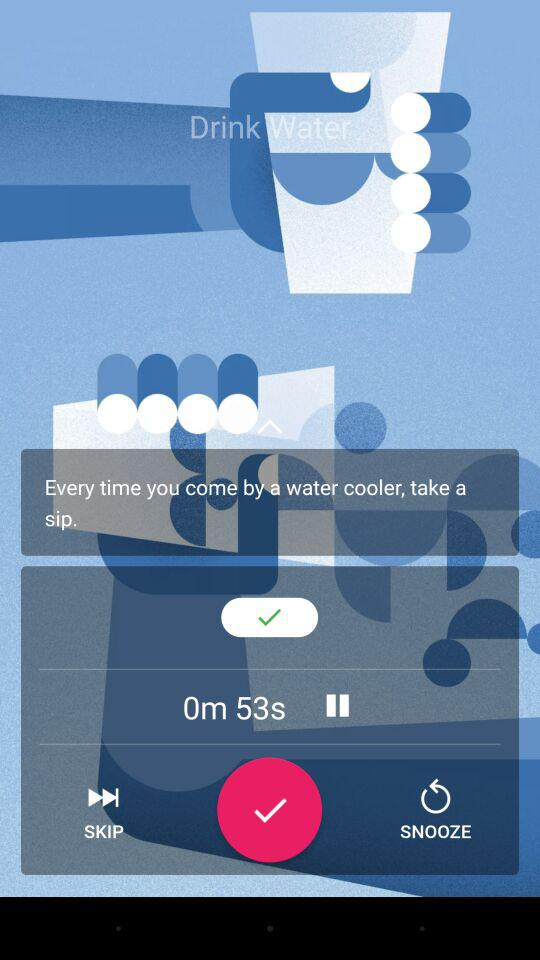How much time has passed since the last sip?
Answer the question using a single word or phrase. 53s 